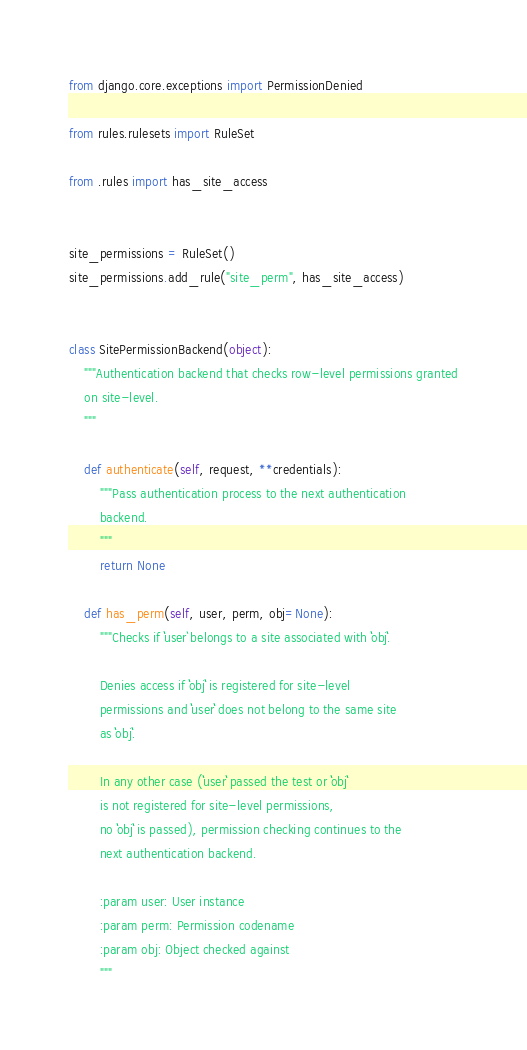Convert code to text. <code><loc_0><loc_0><loc_500><loc_500><_Python_>from django.core.exceptions import PermissionDenied

from rules.rulesets import RuleSet

from .rules import has_site_access


site_permissions = RuleSet()
site_permissions.add_rule("site_perm", has_site_access)


class SitePermissionBackend(object):
    """Authentication backend that checks row-level permissions granted
    on site-level.
    """

    def authenticate(self, request, **credentials):
        """Pass authentication process to the next authentication
        backend.
        """
        return None

    def has_perm(self, user, perm, obj=None):
        """Checks if ``user` belongs to a site associated with ``obj``.

        Denies access if ``obj`` is registered for site-level
        permissions and ``user`` does not belong to the same site
        as ``obj``.

        In any other case (``user`` passed the test or ``obj``
        is not registered for site-level permissions,
        no ``obj`` is passed), permission checking continues to the
        next authentication backend.

        :param user: User instance
        :param perm: Permission codename
        :param obj: Object checked against
        """</code> 